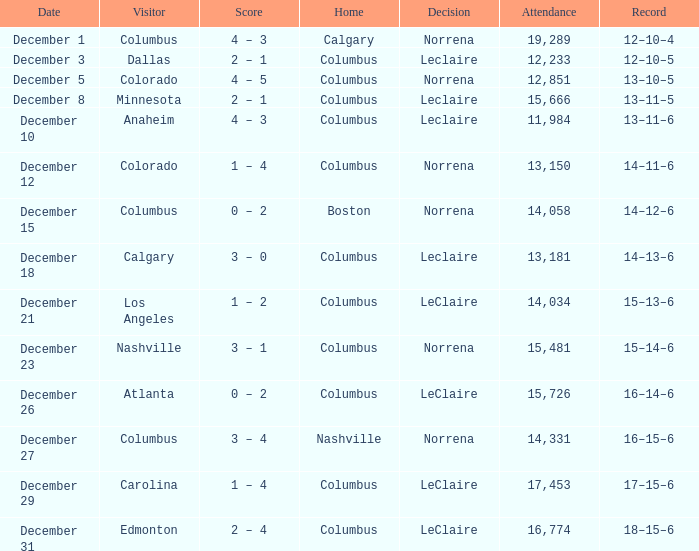What was the score with a 16–14–6 record? 0 – 2. 